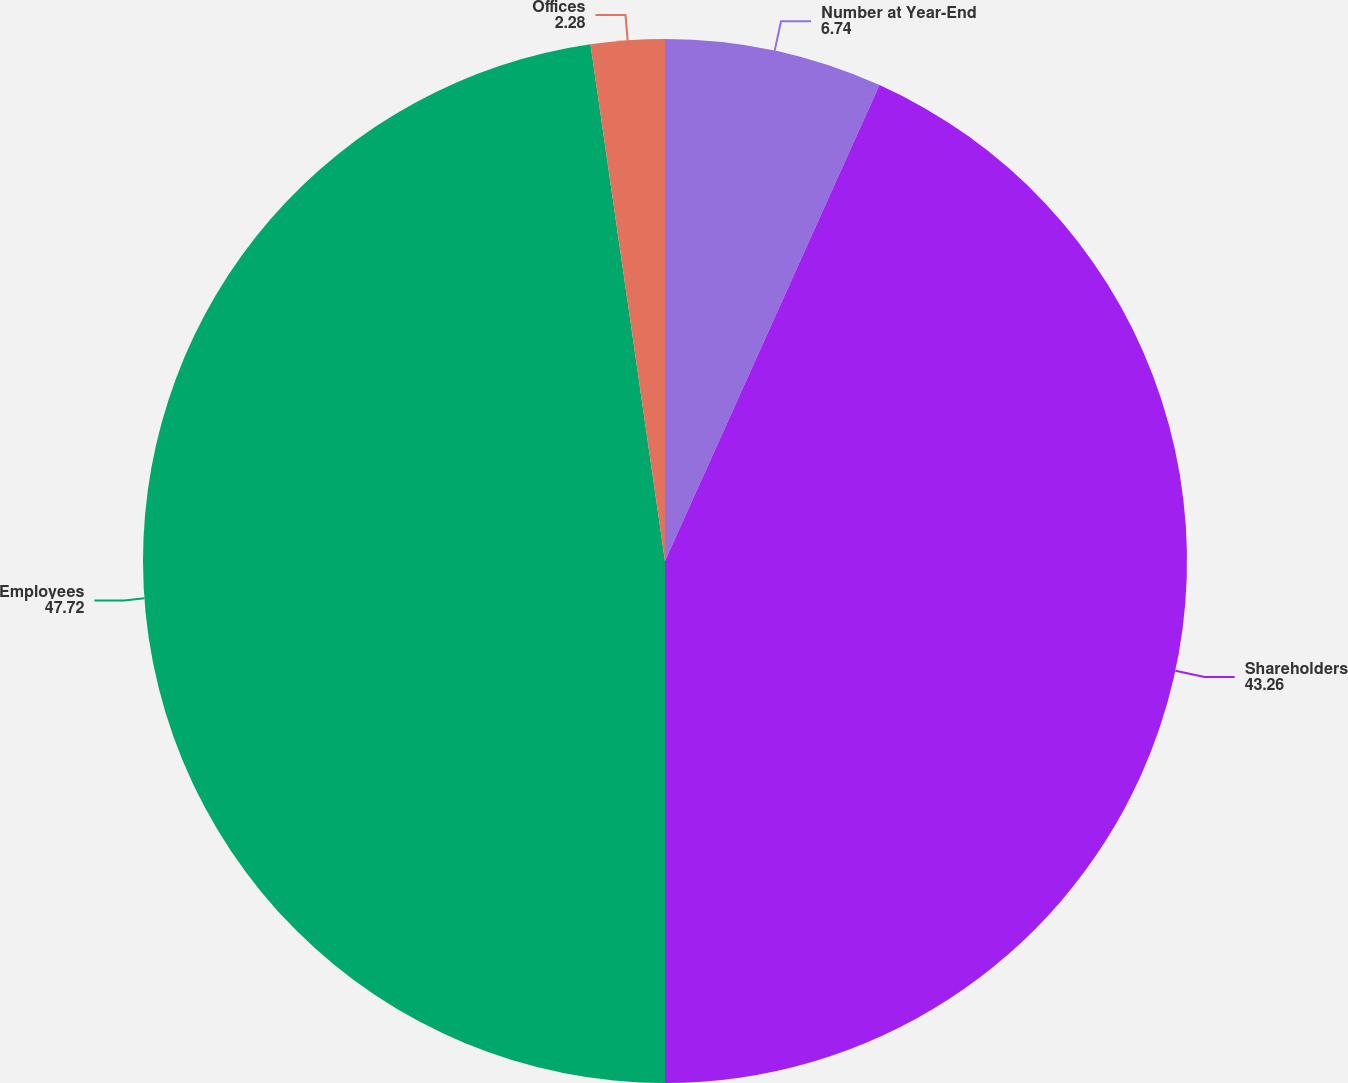Convert chart. <chart><loc_0><loc_0><loc_500><loc_500><pie_chart><fcel>Number at Year-End<fcel>Shareholders<fcel>Employees<fcel>Offices<nl><fcel>6.74%<fcel>43.26%<fcel>47.72%<fcel>2.28%<nl></chart> 